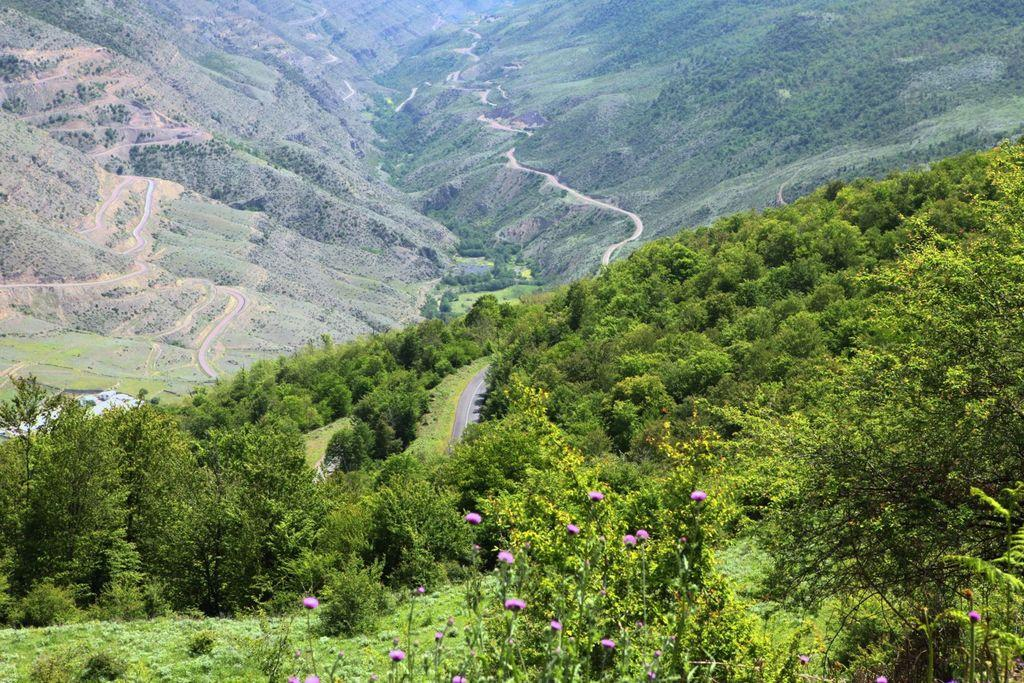What type of plants can be seen in the image? There are plants with flowers in the image. What else is present in the image besides the plants? There is a group of trees, a pathway, and mountains in the background. Can you describe the pathway in the image? The pathway is visible in the image, but its specific characteristics are not mentioned in the provided facts. What natural feature can be seen in the distance in the image? In the background of the image, there are mountains. What type of plastic is used to create the family in the image? There is no mention of a family or plastic in the provided facts, so this question cannot be answered. 